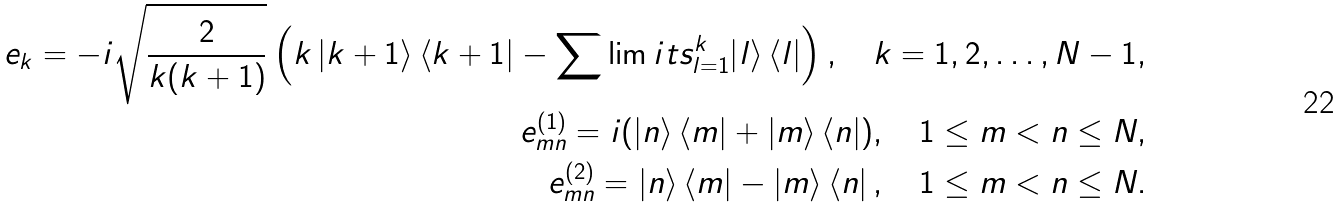Convert formula to latex. <formula><loc_0><loc_0><loc_500><loc_500>e _ { k } = - i \sqrt { \frac { 2 } { k ( k + 1 ) } } \left ( { k \left | k + 1 \right \rangle \left \langle k + 1 \right | - \sum \lim i t s _ { l = 1 } ^ { k } { \left | l \right \rangle } \left \langle l \right | } \right ) , \quad k = 1 , 2 , \dots , N - 1 , \\ e _ { m n } ^ { ( 1 ) } = i ( \left | n \right \rangle \left \langle m \right | + \left | m \right \rangle \left \langle n \right | ) , \quad 1 \leq m < n \leq N , \\ e _ { m n } ^ { ( 2 ) } = \left | n \right \rangle \left \langle m \right | - \left | m \right \rangle \left \langle n \right | , \quad 1 \leq m < n \leq N .</formula> 